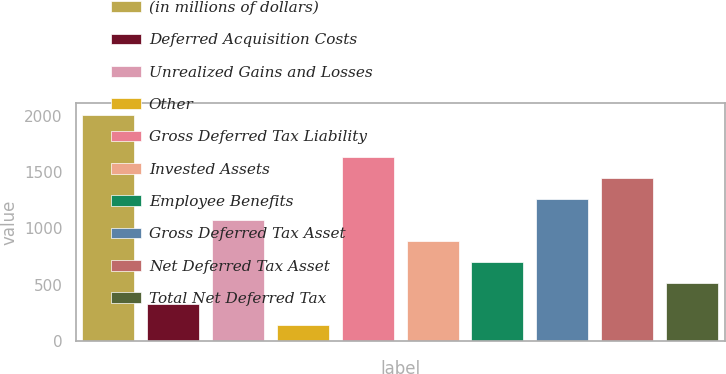Convert chart to OTSL. <chart><loc_0><loc_0><loc_500><loc_500><bar_chart><fcel>(in millions of dollars)<fcel>Deferred Acquisition Costs<fcel>Unrealized Gains and Losses<fcel>Other<fcel>Gross Deferred Tax Liability<fcel>Invested Assets<fcel>Employee Benefits<fcel>Gross Deferred Tax Asset<fcel>Net Deferred Tax Asset<fcel>Total Net Deferred Tax<nl><fcel>2011<fcel>325.48<fcel>1074.6<fcel>138.2<fcel>1636.44<fcel>887.32<fcel>700.04<fcel>1261.88<fcel>1449.16<fcel>512.76<nl></chart> 